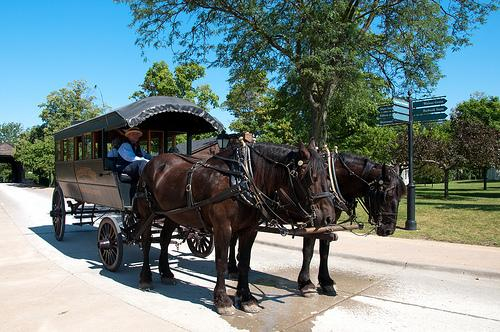Identify the major components in the image. People, horse-drawn carriage, two brown horses, wooden wagon wheels, sign post, trees, bridge, clear blue sky, street, tall tree, and green street signs. What color are the horses and where are they located? The horses are brown and located on the street. What color is the sky and what is its condition? The sky is blue and mostly clear. Mention the elements present in the background of the image. Bridge, mostly clear and blue sky, tall tree behind horse carriage. Count the number of horses in the image and describe their appearance. There are two brown horses with black straps on their heads. List any articles of clothing or accessories that are visible on a person in the image. Hat, long sleeve shirt, dark shirt. Identify any unique features of the sign post. The sign post has several green street signs on a green pole. Describe the structure of the carriage. Dark roof on top, dark wheel, and room for persons inside. What type of tree is behind the horse carriage, and what color are its leaves? A tall tree with green leaves. Briefly describe the scene depicted in the image. The scene shows people in a horse-drawn carriage with two brown horses on a street, a sign post with green street signs, a wooden bridge, and a clear blue sky. Can you describe the features of the red bird perched on top of the street sign? The provided information does not describe any birds, particularly not a red one, and nothing is mentioned about anything perched on the street sign. Try to identify the types of flowers that surround the base of the sign post. No, it's not mentioned in the image. Notice how the people walking beside the carriage are dressed for a formal event. The provided information does not mention any people walking beside the carriage or their attire. 